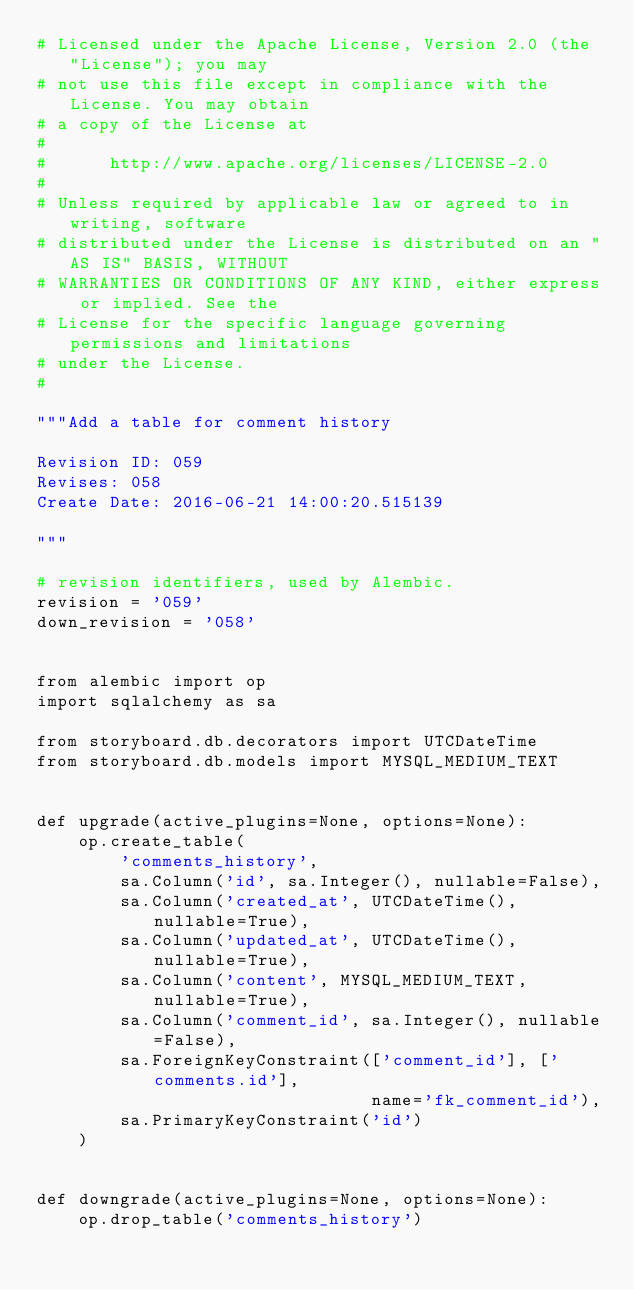Convert code to text. <code><loc_0><loc_0><loc_500><loc_500><_Python_># Licensed under the Apache License, Version 2.0 (the "License"); you may
# not use this file except in compliance with the License. You may obtain
# a copy of the License at
#
#      http://www.apache.org/licenses/LICENSE-2.0
#
# Unless required by applicable law or agreed to in writing, software
# distributed under the License is distributed on an "AS IS" BASIS, WITHOUT
# WARRANTIES OR CONDITIONS OF ANY KIND, either express or implied. See the
# License for the specific language governing permissions and limitations
# under the License.
#

"""Add a table for comment history

Revision ID: 059
Revises: 058
Create Date: 2016-06-21 14:00:20.515139

"""

# revision identifiers, used by Alembic.
revision = '059'
down_revision = '058'


from alembic import op
import sqlalchemy as sa

from storyboard.db.decorators import UTCDateTime
from storyboard.db.models import MYSQL_MEDIUM_TEXT


def upgrade(active_plugins=None, options=None):
    op.create_table(
        'comments_history',
        sa.Column('id', sa.Integer(), nullable=False),
        sa.Column('created_at', UTCDateTime(), nullable=True),
        sa.Column('updated_at', UTCDateTime(), nullable=True),
        sa.Column('content', MYSQL_MEDIUM_TEXT, nullable=True),
        sa.Column('comment_id', sa.Integer(), nullable=False),
        sa.ForeignKeyConstraint(['comment_id'], ['comments.id'],
                                name='fk_comment_id'),
        sa.PrimaryKeyConstraint('id')
    )


def downgrade(active_plugins=None, options=None):
    op.drop_table('comments_history')
</code> 